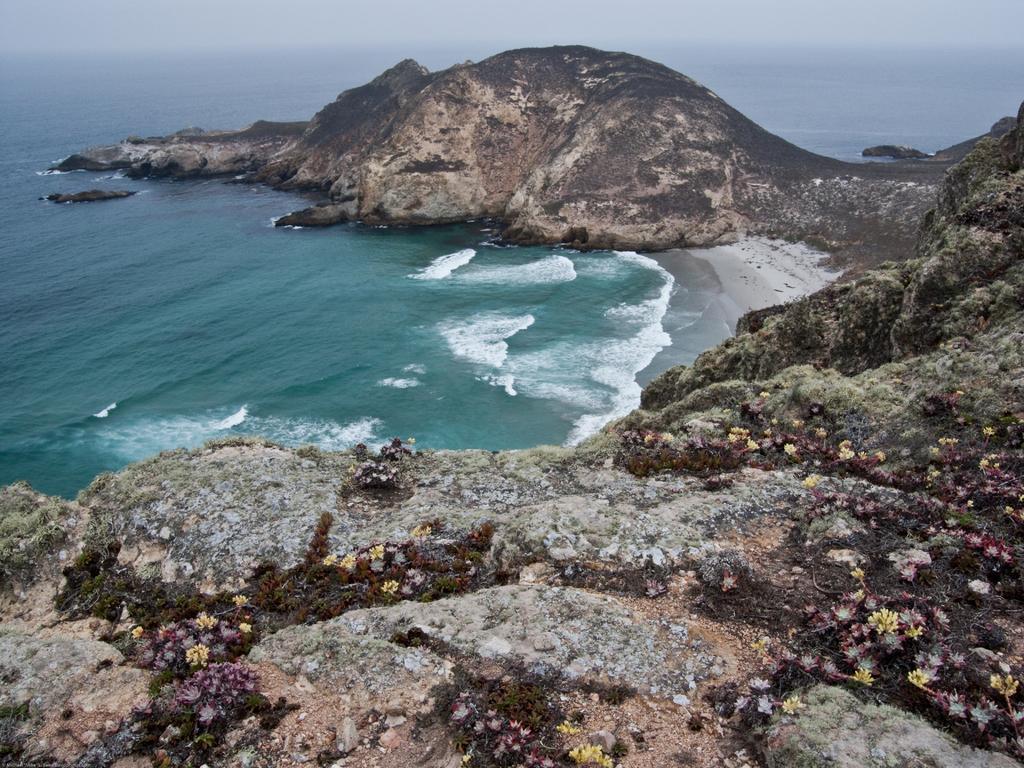In one or two sentences, can you explain what this image depicts? There is a sea and around the sea there is a huge rock hill. 